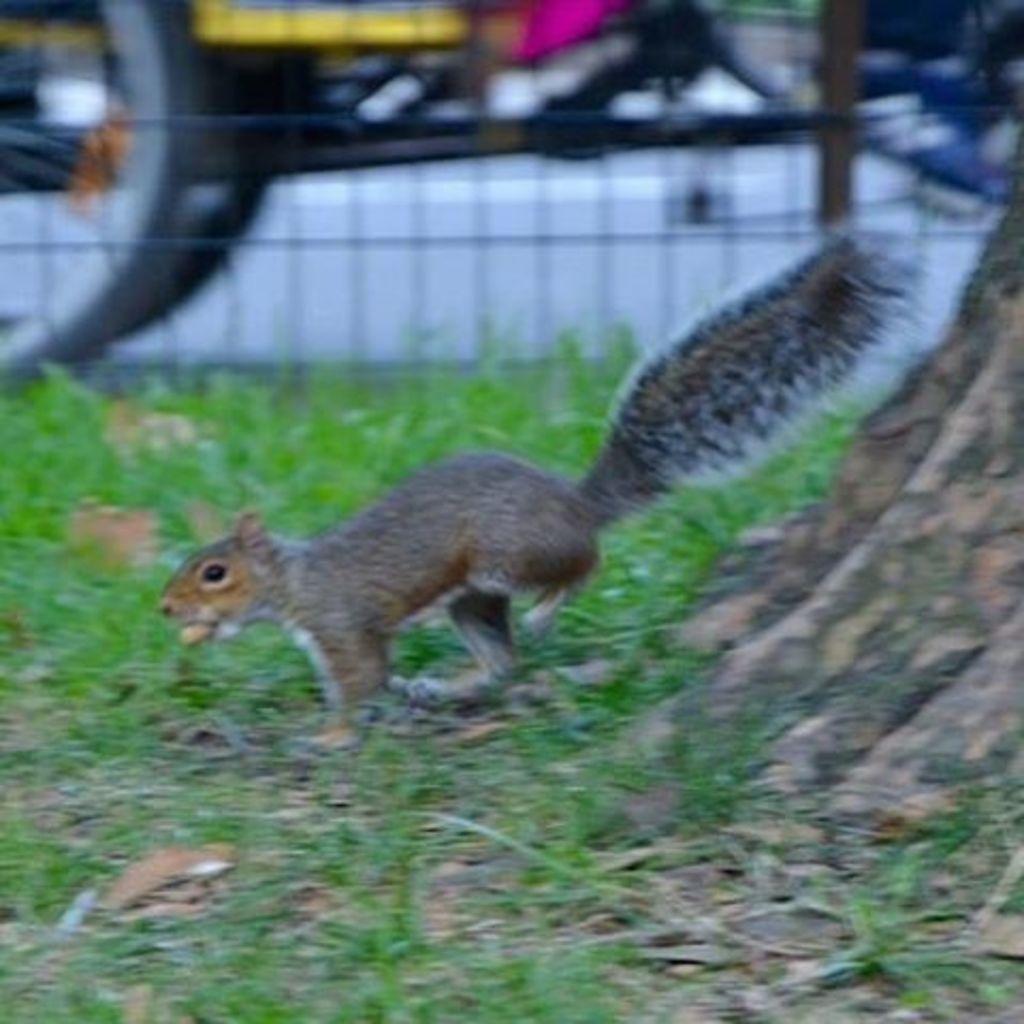Could you give a brief overview of what you see in this image? In the picture,there is squirrel moving on the grass and behind the grass there is a mesh and the background is blurry. 